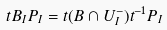Convert formula to latex. <formula><loc_0><loc_0><loc_500><loc_500>t B _ { I } P _ { I } = t ( B \cap U _ { I } ^ { - } ) t ^ { - 1 } P _ { I }</formula> 